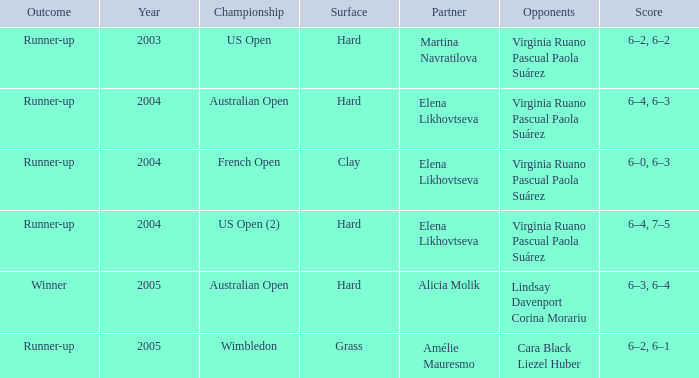When the victor is the result, what is the tally? 6–3, 6–4. 